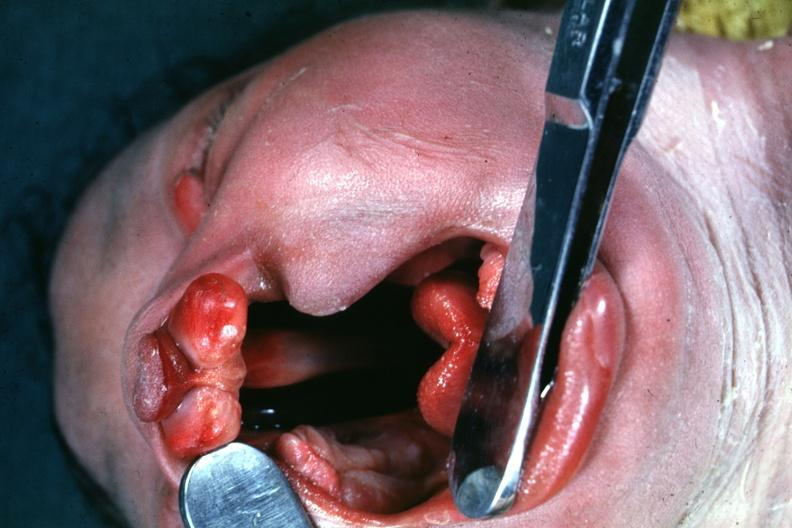how is head tilted with mouth opened to show defect very good illustration of this lesion?
Answer the question using a single word or phrase. Large 